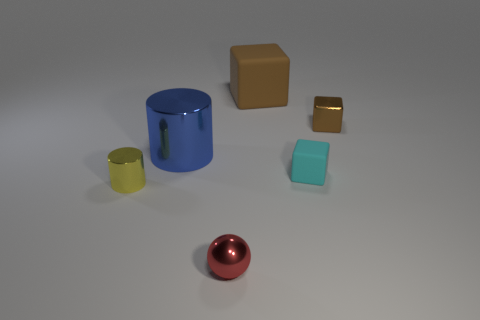The objects appear to be arranged on a flat surface. Is there any discernible pattern or arrangement to how they are placed? The objects seem to be randomly arranged without a discernible pattern. They are spaced out across the surface, each separated from the others, suggesting no intentional grouping or alignment. Could you guess the material the objects might be made of based on their appearance? Based on their appearance, the objects could be made from a variety of materials. The cylinders and the sphere seem to have a metallic look, the cube possibly an opaque matte surface, and the rectangular prism seems to have a slightly translucent or plastic quality. 